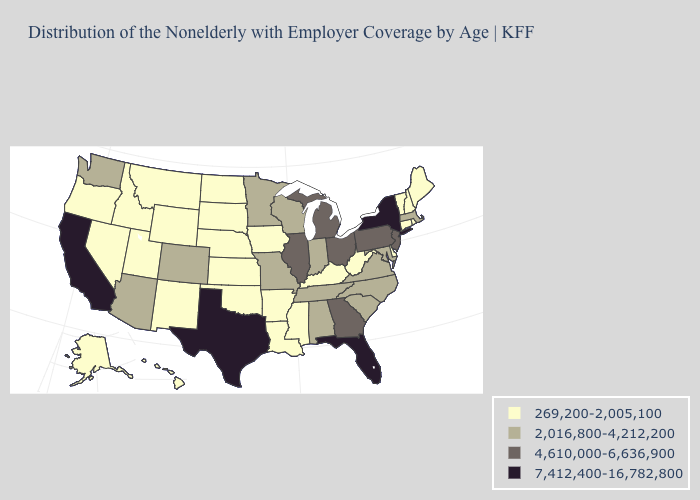Which states have the lowest value in the West?
Keep it brief. Alaska, Hawaii, Idaho, Montana, Nevada, New Mexico, Oregon, Utah, Wyoming. What is the value of Delaware?
Quick response, please. 269,200-2,005,100. Does Mississippi have the lowest value in the South?
Answer briefly. Yes. What is the lowest value in states that border Connecticut?
Write a very short answer. 269,200-2,005,100. Which states hav the highest value in the South?
Concise answer only. Florida, Texas. Among the states that border Missouri , does Tennessee have the lowest value?
Write a very short answer. No. Name the states that have a value in the range 4,610,000-6,636,900?
Short answer required. Georgia, Illinois, Michigan, New Jersey, Ohio, Pennsylvania. Does Alaska have a lower value than California?
Keep it brief. Yes. What is the value of South Dakota?
Short answer required. 269,200-2,005,100. Name the states that have a value in the range 269,200-2,005,100?
Keep it brief. Alaska, Arkansas, Connecticut, Delaware, Hawaii, Idaho, Iowa, Kansas, Kentucky, Louisiana, Maine, Mississippi, Montana, Nebraska, Nevada, New Hampshire, New Mexico, North Dakota, Oklahoma, Oregon, Rhode Island, South Dakota, Utah, Vermont, West Virginia, Wyoming. What is the value of Arkansas?
Keep it brief. 269,200-2,005,100. What is the lowest value in the USA?
Short answer required. 269,200-2,005,100. What is the lowest value in the South?
Give a very brief answer. 269,200-2,005,100. What is the highest value in states that border Minnesota?
Be succinct. 2,016,800-4,212,200. Among the states that border Indiana , does Kentucky have the highest value?
Keep it brief. No. 